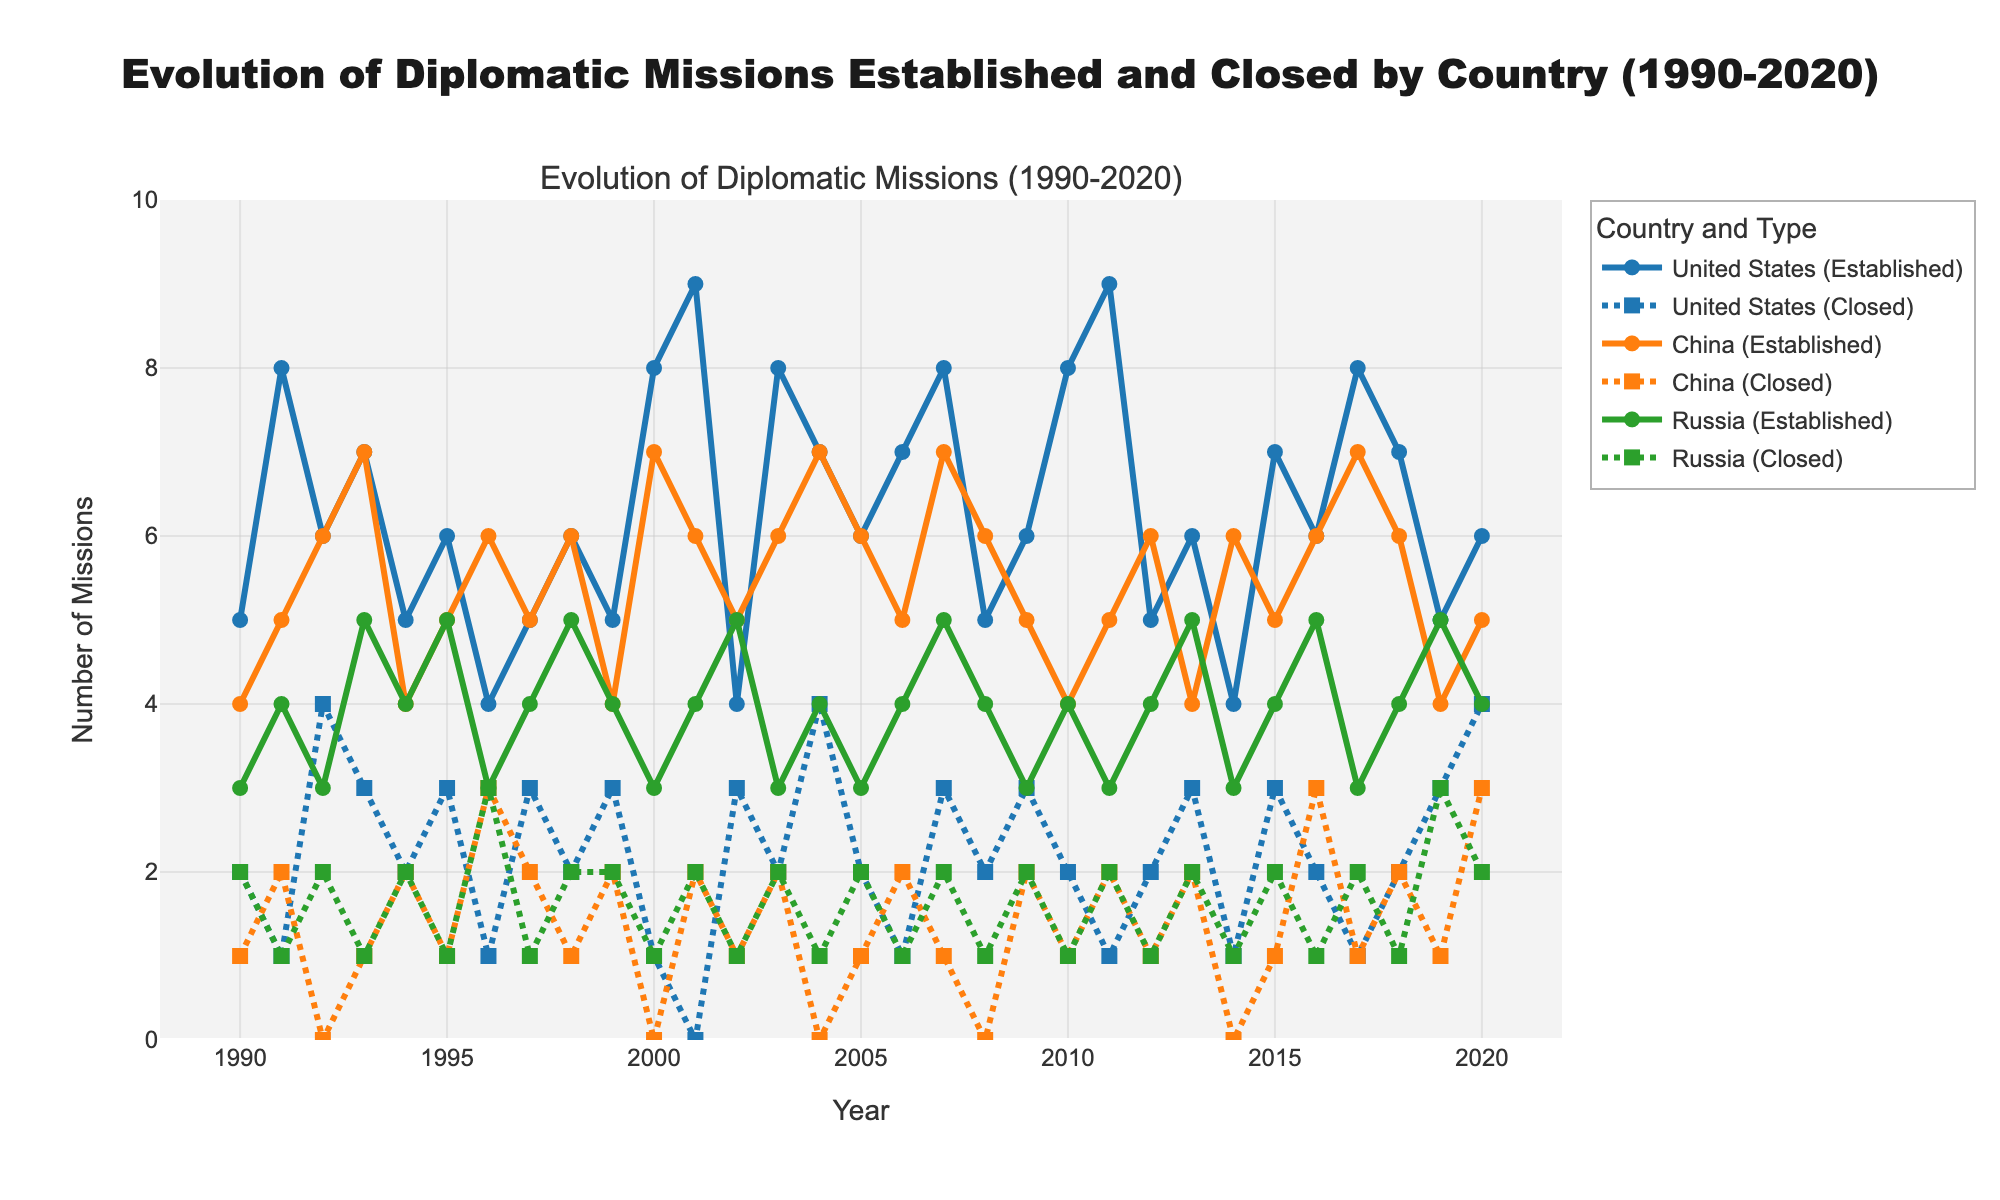What is the main title of the figure? The main title of the figure is located at the top and describes what the figure represents. It is mentioned in a large font.
Answer: Evolution of Diplomatic Missions Established and Closed by Country (1990-2020) How many countries are compared in the figure? The legend indicates three distinct colors representing three different countries.
Answer: Three Which country established the highest number of diplomatic missions in any single year? By examining the peaks in the lines representing established missions, the highest single-year value belongs to the United States in 2001 reaching 9 missions.
Answer: United States What is the general trend for closed missions for Russia from 1990 to 2020? By observing the dashed line for Russia, the number of closed missions generally fluctuates between 1 and 2 with rare increments to 3, but doesn’t show a continuous upward or downward trend.
Answer: Fluctuates between 1 and 3 During which years did China open 7 diplomatic missions? By checking the years where the line for established missions of China reaches 7 on the y-axis, we see it occurs in 1993, 2000, 2004, and 2017.
Answer: 1993, 2000, 2004, 2017 What is the year with the highest number of closed missions for the United States? By looking at the dashed line for closed missions of the United States and identifying the highest peak, we find it is in the year 2020 with 4 closed missions.
Answer: 2020 Is there any year where all three countries established exactly 5 missions? By following the lines for established missions for all countries and finding a common intersection at 5 on the y-axis, this occurs in 1997.
Answer: 1997 What's the average number of established missions by the United States in the 1990s? Summing the values from 1990 to 1999 (5+8+6+7+5+6+4+5+6+5) and dividing by 10 gives the average: (57/10)
Answer: 5.7 Which country closed the least number of diplomatic missions over the period 2005-2010? Summing the values for each country from 2005 to 2010 and comparing them: United States (2+1+3+2+3+2), China (1+2+1+0+2+1), Russia (2+1+2+1+2+1). The smallest total is China.
Answer: China Compare the trends of established missions between China and the United States from 2000 to 2010. By observing the lines for established missions for both countries from 2000-2010: Both countries show fluctuation, but the values for the United States generally remain higher, particularly peaking in 2001 and 2010, while China has more moderate increases.
Answer: The United States generally has higher values and fluctuations 